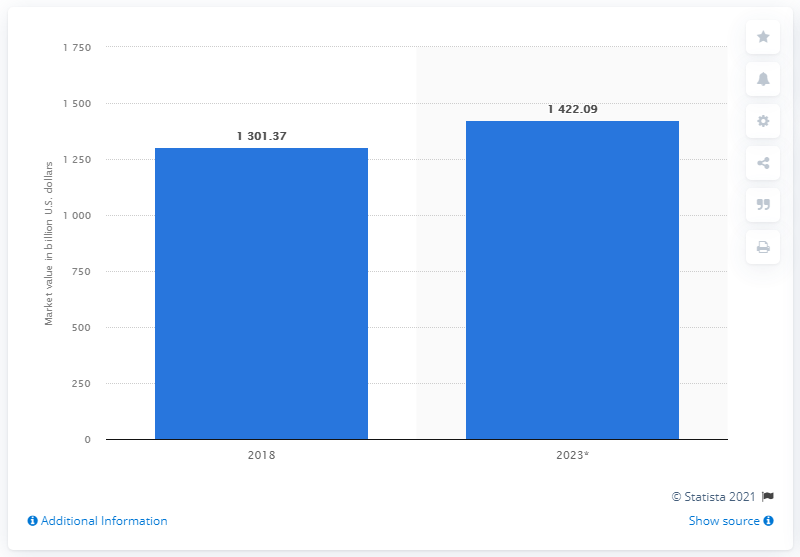List a handful of essential elements in this visual. The global market value of nuts and seeds in 2018 was approximately 1,301.37. 